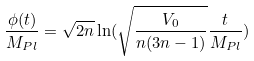Convert formula to latex. <formula><loc_0><loc_0><loc_500><loc_500>\frac { \phi ( t ) } { M _ { P l } } = \sqrt { 2 n } \ln ( \sqrt { \frac { V _ { 0 } } { n ( 3 n - 1 ) } } \frac { t } { M _ { P l } } )</formula> 